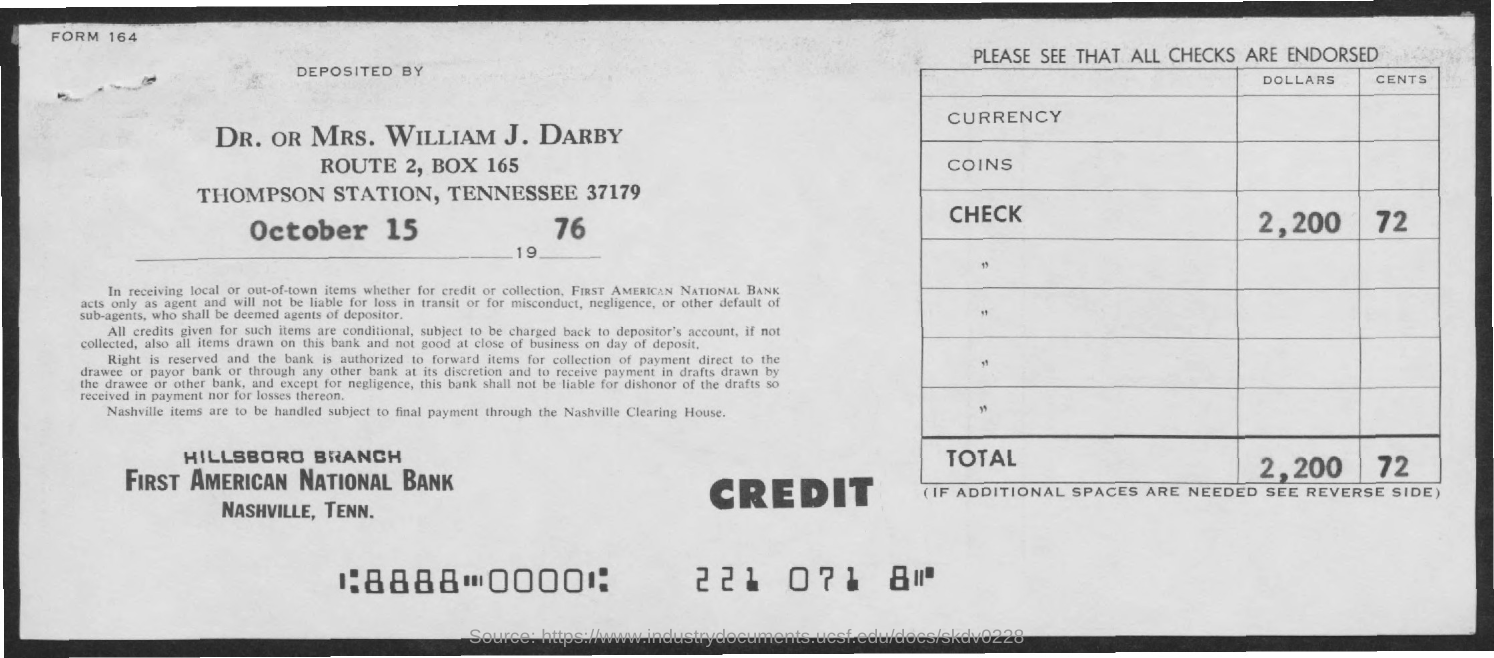Highlight a few significant elements in this photo. On October 15, 1976, the amount was deposited. 